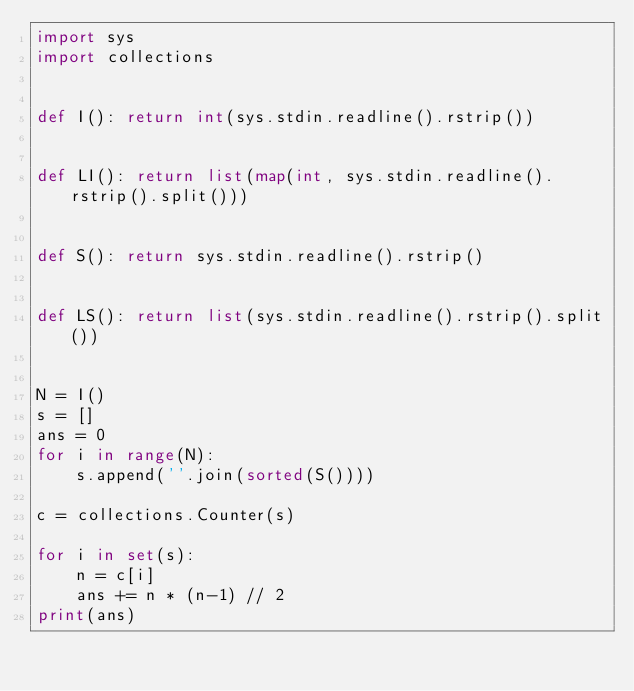<code> <loc_0><loc_0><loc_500><loc_500><_Python_>import sys
import collections


def I(): return int(sys.stdin.readline().rstrip())


def LI(): return list(map(int, sys.stdin.readline().rstrip().split()))


def S(): return sys.stdin.readline().rstrip()


def LS(): return list(sys.stdin.readline().rstrip().split())


N = I()
s = []
ans = 0
for i in range(N):
    s.append(''.join(sorted(S())))

c = collections.Counter(s)

for i in set(s):
    n = c[i]
    ans += n * (n-1) // 2
print(ans)
</code> 